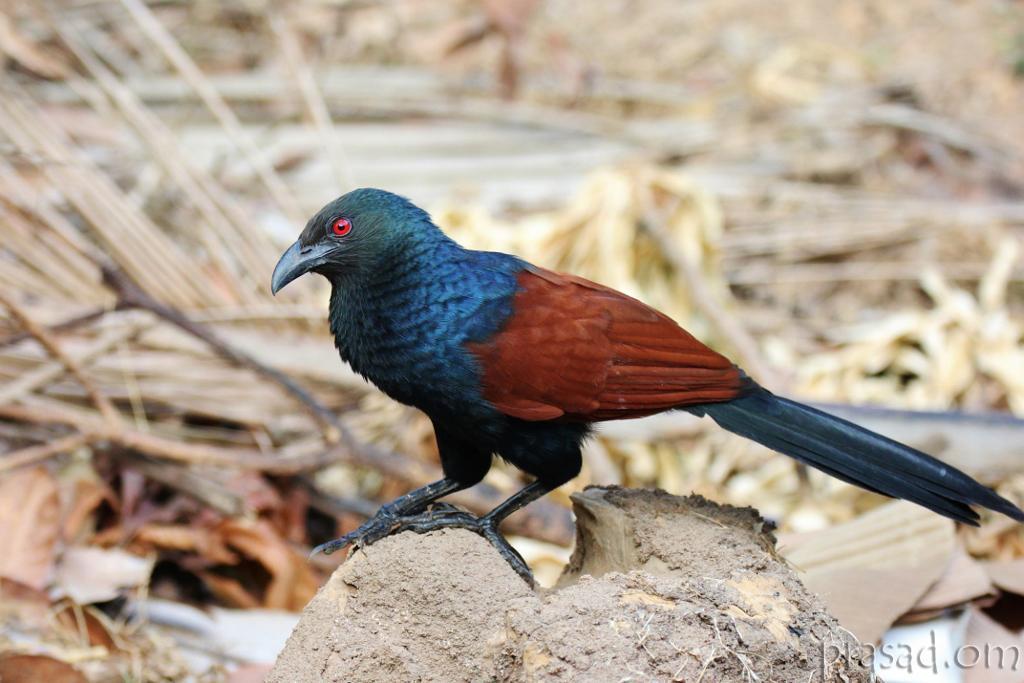Please provide a concise description of this image. In the center of the image, we can see a bird on the trunk and in the background, there are twigs and there is some text. 